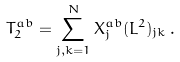Convert formula to latex. <formula><loc_0><loc_0><loc_500><loc_500>T _ { 2 } ^ { a b } = \sum _ { j , k = 1 } ^ { N } X _ { j } ^ { a b } ( L ^ { 2 } ) _ { j k } \, .</formula> 